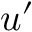Convert formula to latex. <formula><loc_0><loc_0><loc_500><loc_500>u ^ { \prime }</formula> 